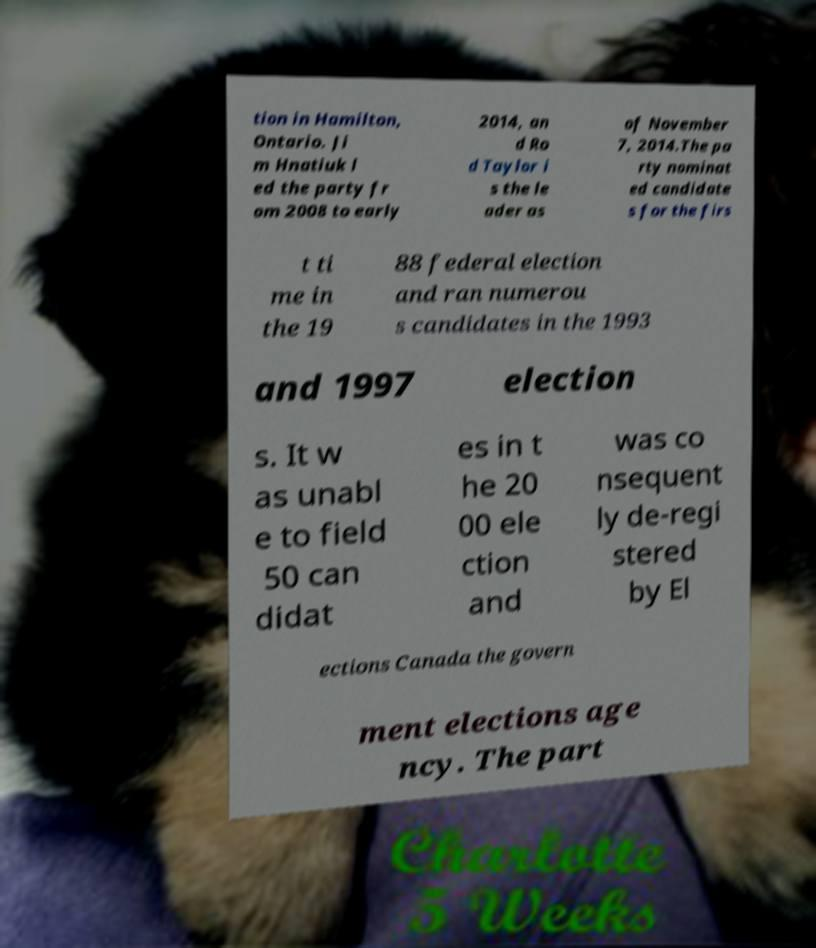For documentation purposes, I need the text within this image transcribed. Could you provide that? tion in Hamilton, Ontario. Ji m Hnatiuk l ed the party fr om 2008 to early 2014, an d Ro d Taylor i s the le ader as of November 7, 2014.The pa rty nominat ed candidate s for the firs t ti me in the 19 88 federal election and ran numerou s candidates in the 1993 and 1997 election s. It w as unabl e to field 50 can didat es in t he 20 00 ele ction and was co nsequent ly de-regi stered by El ections Canada the govern ment elections age ncy. The part 